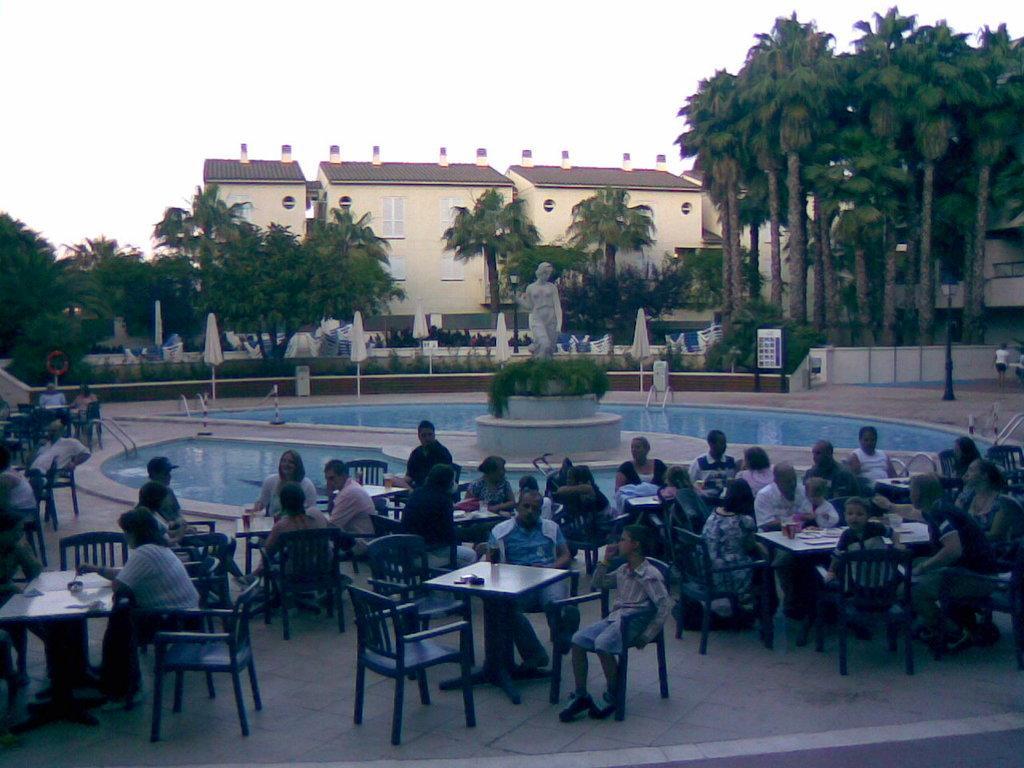Can you describe this image briefly? In middle of this pool there is a sculpture. Persons are sitting on chairs, in-front of them there are tables. Far there are number of trees and building with window. On this table there is a cup. 